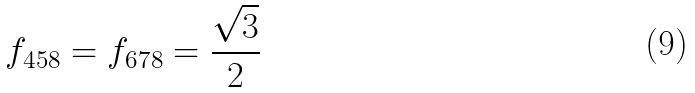Convert formula to latex. <formula><loc_0><loc_0><loc_500><loc_500>f _ { 4 5 8 } = f _ { 6 7 8 } = \frac { \sqrt { 3 } } { 2 }</formula> 